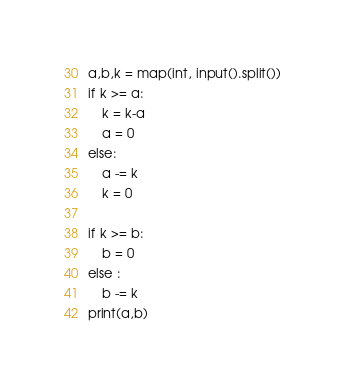Convert code to text. <code><loc_0><loc_0><loc_500><loc_500><_Python_>a,b,k = map(int, input().split())
if k >= a:
    k = k-a
    a = 0
else:
    a -= k
    k = 0

if k >= b:
    b = 0
else :
    b -= k
print(a,b)</code> 